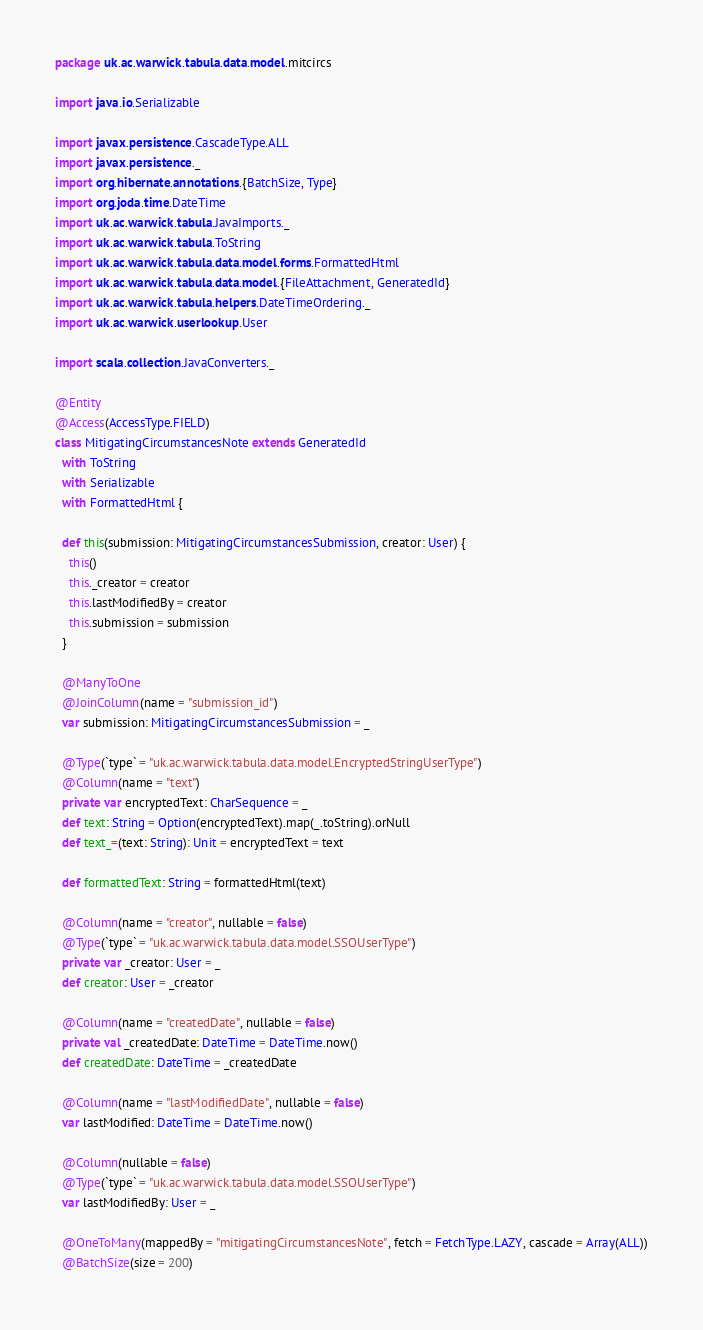Convert code to text. <code><loc_0><loc_0><loc_500><loc_500><_Scala_>package uk.ac.warwick.tabula.data.model.mitcircs

import java.io.Serializable

import javax.persistence.CascadeType.ALL
import javax.persistence._
import org.hibernate.annotations.{BatchSize, Type}
import org.joda.time.DateTime
import uk.ac.warwick.tabula.JavaImports._
import uk.ac.warwick.tabula.ToString
import uk.ac.warwick.tabula.data.model.forms.FormattedHtml
import uk.ac.warwick.tabula.data.model.{FileAttachment, GeneratedId}
import uk.ac.warwick.tabula.helpers.DateTimeOrdering._
import uk.ac.warwick.userlookup.User

import scala.collection.JavaConverters._

@Entity
@Access(AccessType.FIELD)
class MitigatingCircumstancesNote extends GeneratedId
  with ToString
  with Serializable
  with FormattedHtml {

  def this(submission: MitigatingCircumstancesSubmission, creator: User) {
    this()
    this._creator = creator
    this.lastModifiedBy = creator
    this.submission = submission
  }

  @ManyToOne
  @JoinColumn(name = "submission_id")
  var submission: MitigatingCircumstancesSubmission = _

  @Type(`type` = "uk.ac.warwick.tabula.data.model.EncryptedStringUserType")
  @Column(name = "text")
  private var encryptedText: CharSequence = _
  def text: String = Option(encryptedText).map(_.toString).orNull
  def text_=(text: String): Unit = encryptedText = text

  def formattedText: String = formattedHtml(text)

  @Column(name = "creator", nullable = false)
  @Type(`type` = "uk.ac.warwick.tabula.data.model.SSOUserType")
  private var _creator: User = _
  def creator: User = _creator

  @Column(name = "createdDate", nullable = false)
  private val _createdDate: DateTime = DateTime.now()
  def createdDate: DateTime = _createdDate

  @Column(name = "lastModifiedDate", nullable = false)
  var lastModified: DateTime = DateTime.now()

  @Column(nullable = false)
  @Type(`type` = "uk.ac.warwick.tabula.data.model.SSOUserType")
  var lastModifiedBy: User = _

  @OneToMany(mappedBy = "mitigatingCircumstancesNote", fetch = FetchType.LAZY, cascade = Array(ALL))
  @BatchSize(size = 200)</code> 